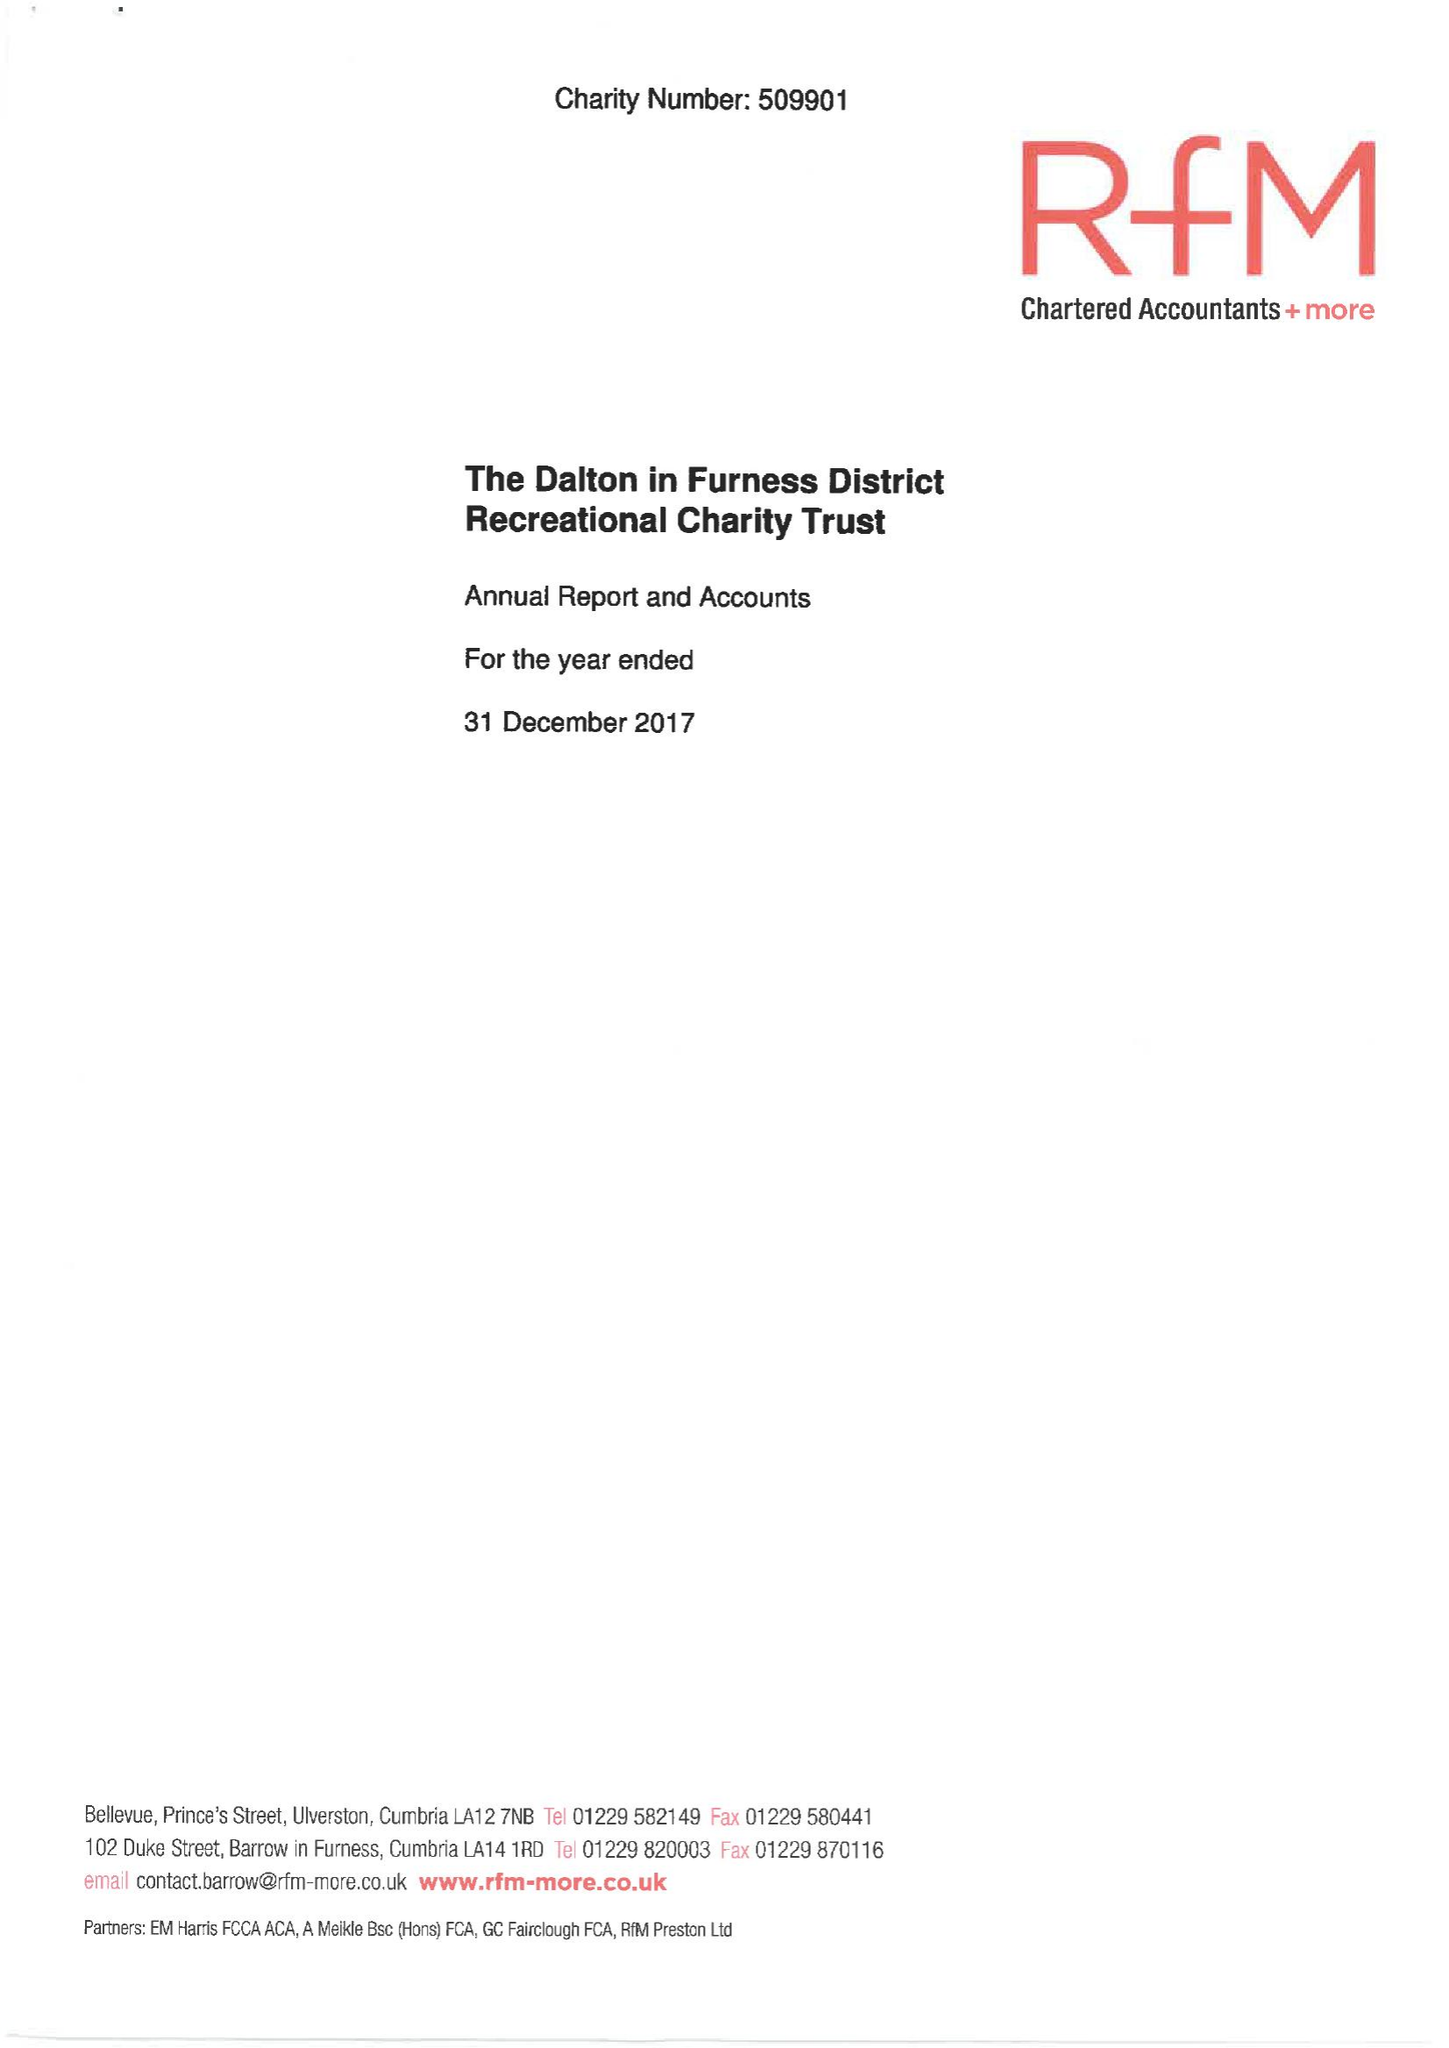What is the value for the income_annually_in_british_pounds?
Answer the question using a single word or phrase. 28258.00 